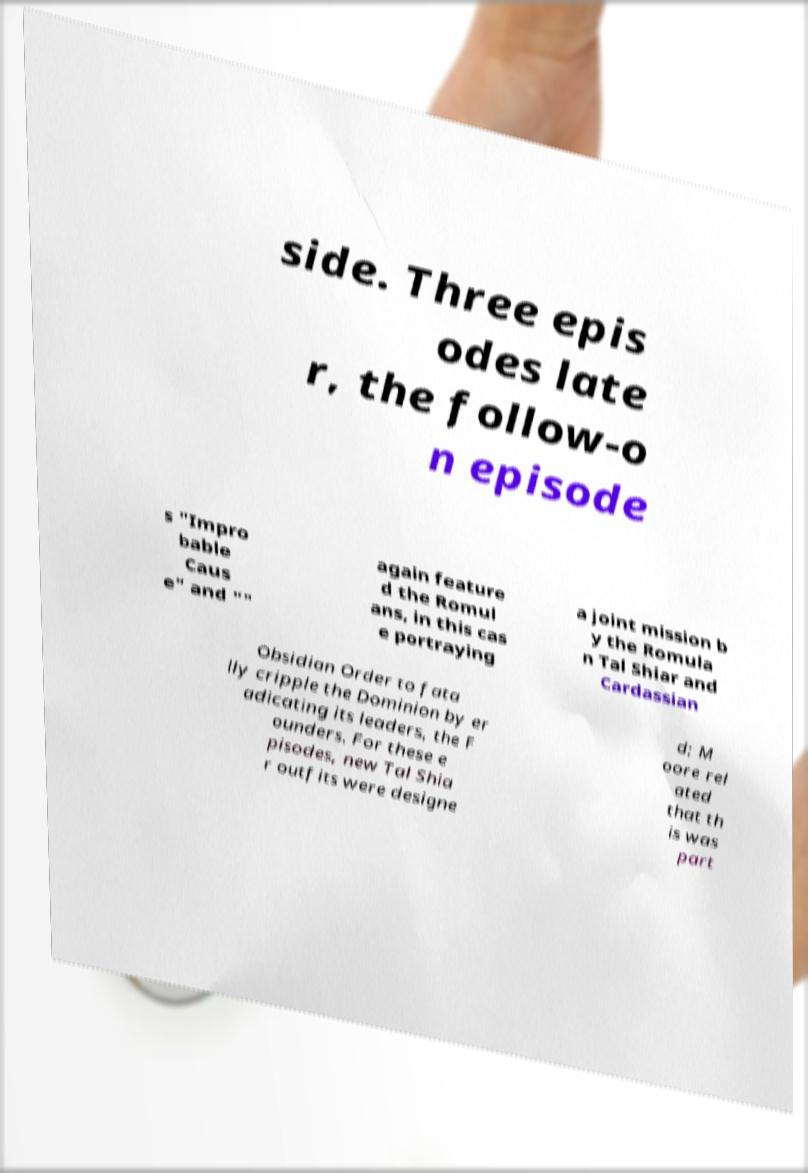Please read and relay the text visible in this image. What does it say? side. Three epis odes late r, the follow-o n episode s "Impro bable Caus e" and "" again feature d the Romul ans, in this cas e portraying a joint mission b y the Romula n Tal Shiar and Cardassian Obsidian Order to fata lly cripple the Dominion by er adicating its leaders, the F ounders. For these e pisodes, new Tal Shia r outfits were designe d; M oore rel ated that th is was part 